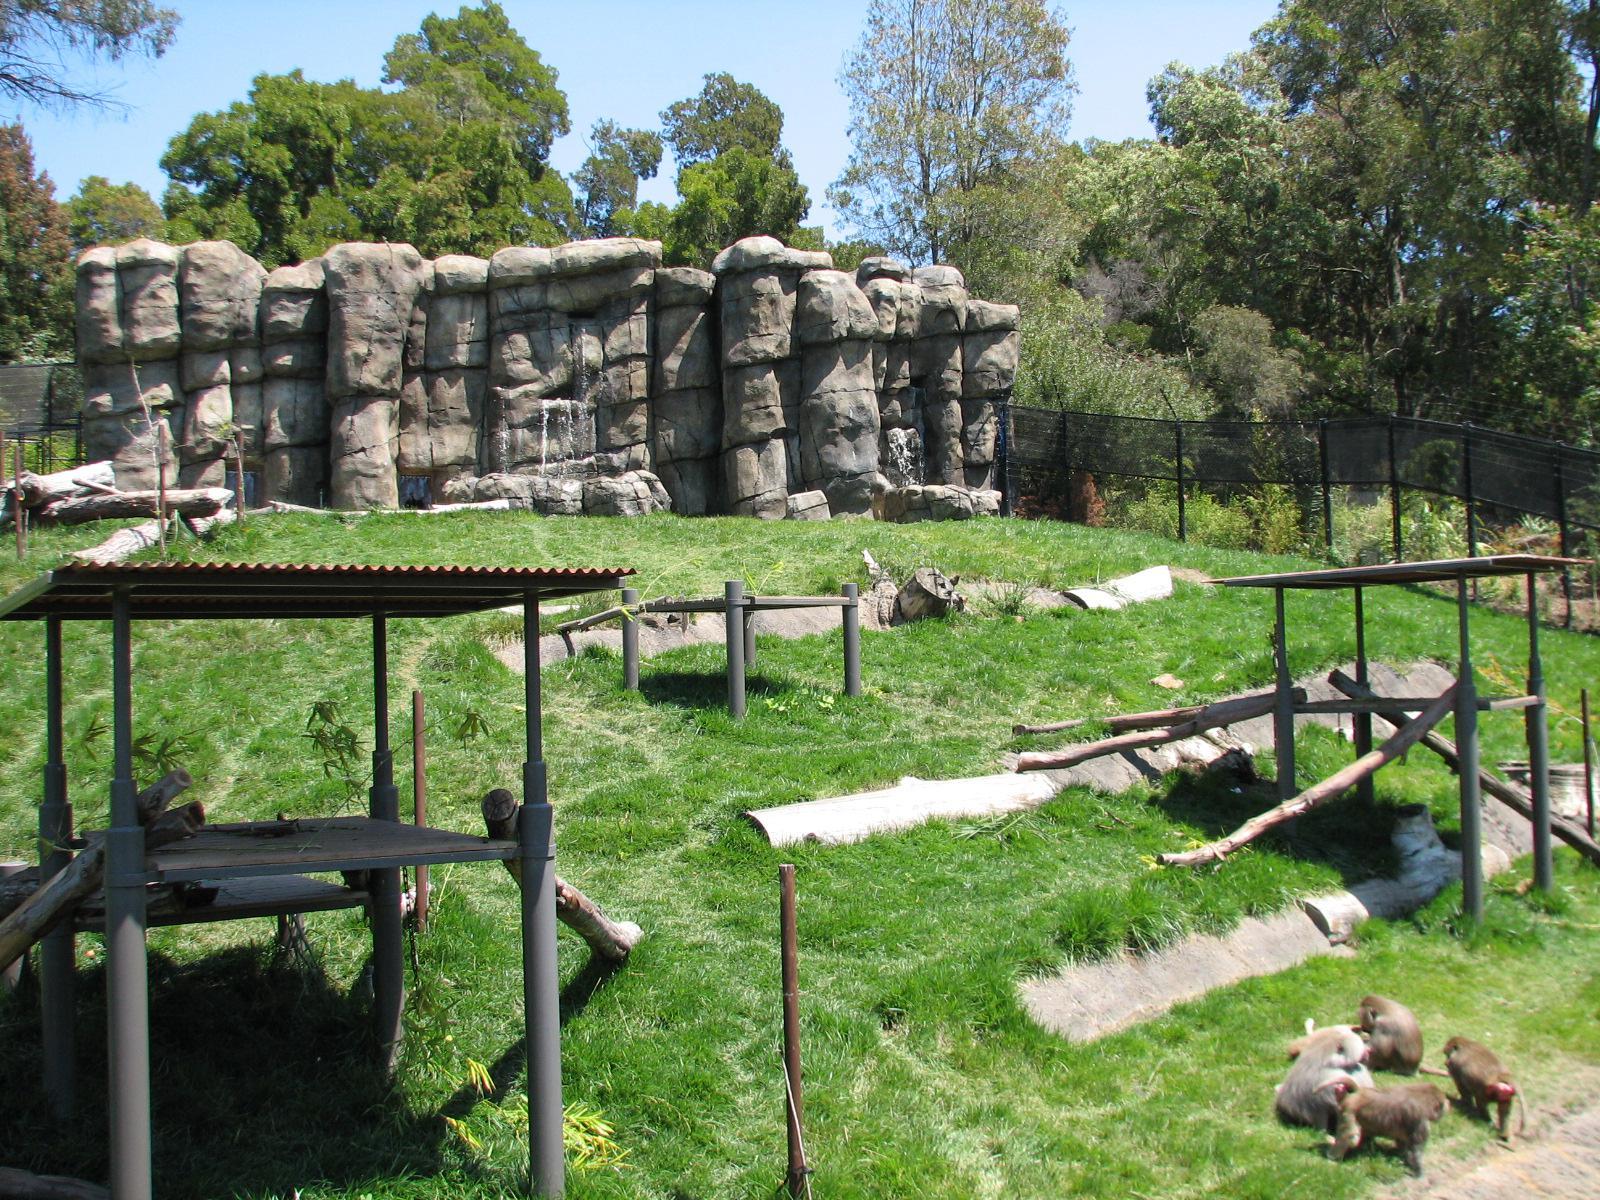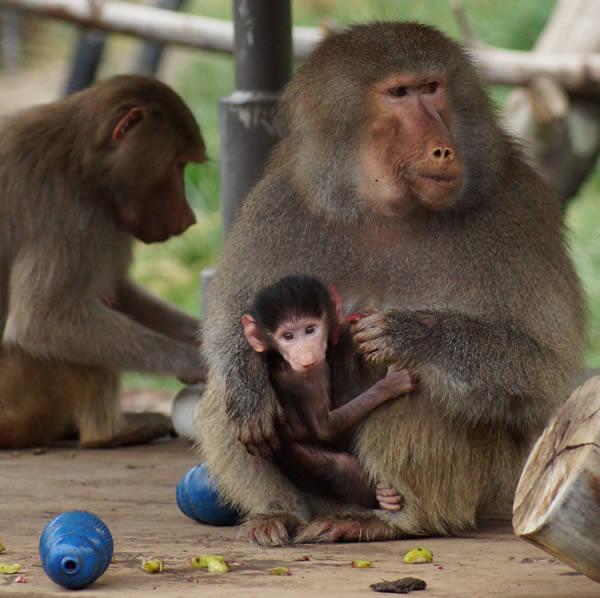The first image is the image on the left, the second image is the image on the right. For the images shown, is this caption "One image shows a baby baboon riding on the body of a baboon in profile on all fours." true? Answer yes or no. No. The first image is the image on the left, the second image is the image on the right. For the images displayed, is the sentence "The left image contains no more than two primates." factually correct? Answer yes or no. No. 